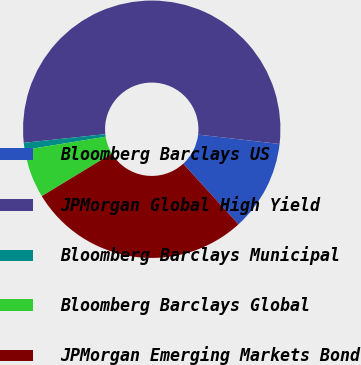Convert chart to OTSL. <chart><loc_0><loc_0><loc_500><loc_500><pie_chart><fcel>Bloomberg Barclays US<fcel>JPMorgan Global High Yield<fcel>Bloomberg Barclays Municipal<fcel>Bloomberg Barclays Global<fcel>JPMorgan Emerging Markets Bond<nl><fcel>11.4%<fcel>53.51%<fcel>0.88%<fcel>6.14%<fcel>28.07%<nl></chart> 